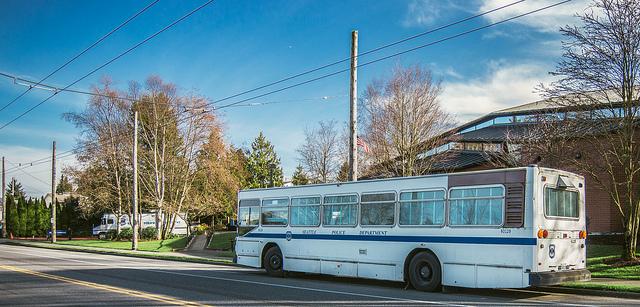Is this a sunny day?
Concise answer only. Yes. Is this a newer bus?
Concise answer only. No. Where is this bus going?
Be succinct. Down street. 